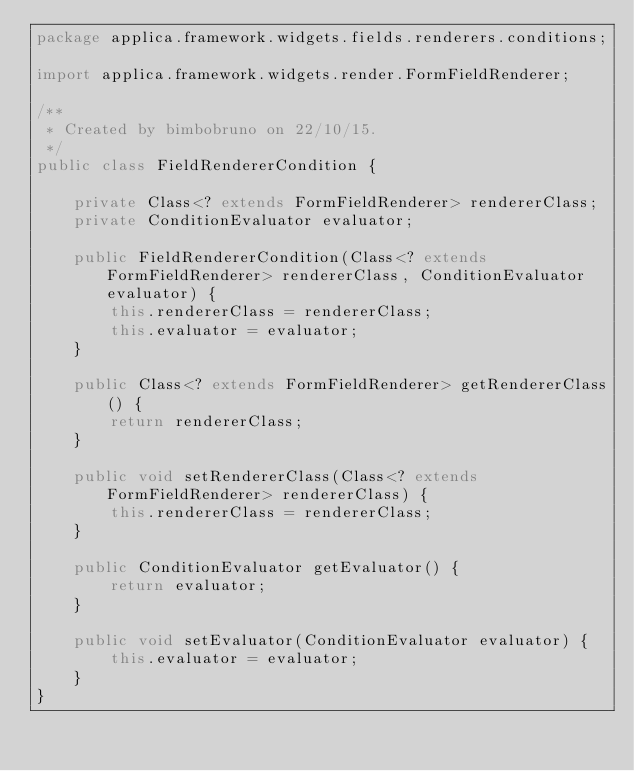<code> <loc_0><loc_0><loc_500><loc_500><_Java_>package applica.framework.widgets.fields.renderers.conditions;

import applica.framework.widgets.render.FormFieldRenderer;

/**
 * Created by bimbobruno on 22/10/15.
 */
public class FieldRendererCondition {

    private Class<? extends FormFieldRenderer> rendererClass;
    private ConditionEvaluator evaluator;

    public FieldRendererCondition(Class<? extends FormFieldRenderer> rendererClass, ConditionEvaluator evaluator) {
        this.rendererClass = rendererClass;
        this.evaluator = evaluator;
    }

    public Class<? extends FormFieldRenderer> getRendererClass() {
        return rendererClass;
    }

    public void setRendererClass(Class<? extends FormFieldRenderer> rendererClass) {
        this.rendererClass = rendererClass;
    }

    public ConditionEvaluator getEvaluator() {
        return evaluator;
    }

    public void setEvaluator(ConditionEvaluator evaluator) {
        this.evaluator = evaluator;
    }
}
</code> 